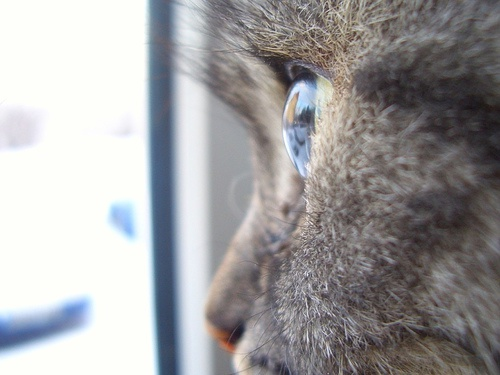Describe the objects in this image and their specific colors. I can see a cat in white, gray, darkgray, and black tones in this image. 